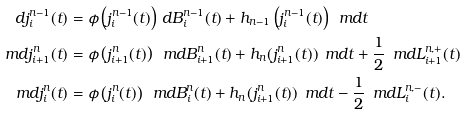<formula> <loc_0><loc_0><loc_500><loc_500>d j ^ { n - 1 } _ { i } ( t ) & = \phi \left ( j _ { i } ^ { n - 1 } ( t ) \right ) \, d B _ { i } ^ { n - 1 } ( t ) + h _ { n - 1 } \left ( j ^ { n - 1 } _ { i } ( t ) \right ) \, \ m d t \\ \ m d j _ { i + 1 } ^ { n } ( t ) & = \phi \left ( j _ { i + 1 } ^ { n } ( t ) \right ) \, \ m d B _ { i + 1 } ^ { n } ( t ) + h _ { n } ( j _ { i + 1 } ^ { n } ( t ) ) \, \ m d t + \frac { 1 } { 2 } \, \ m d L _ { i + 1 } ^ { n , + } ( t ) \\ \ m d j _ { i } ^ { n } ( t ) & = \phi \left ( j _ { i } ^ { n } ( t ) \right ) \, \ m d B _ { i } ^ { n } ( t ) + h _ { n } ( j _ { i + 1 } ^ { n } ( t ) ) \, \ m d t - \frac { 1 } { 2 } \, \ m d L _ { i } ^ { n , - } ( t ) .</formula> 